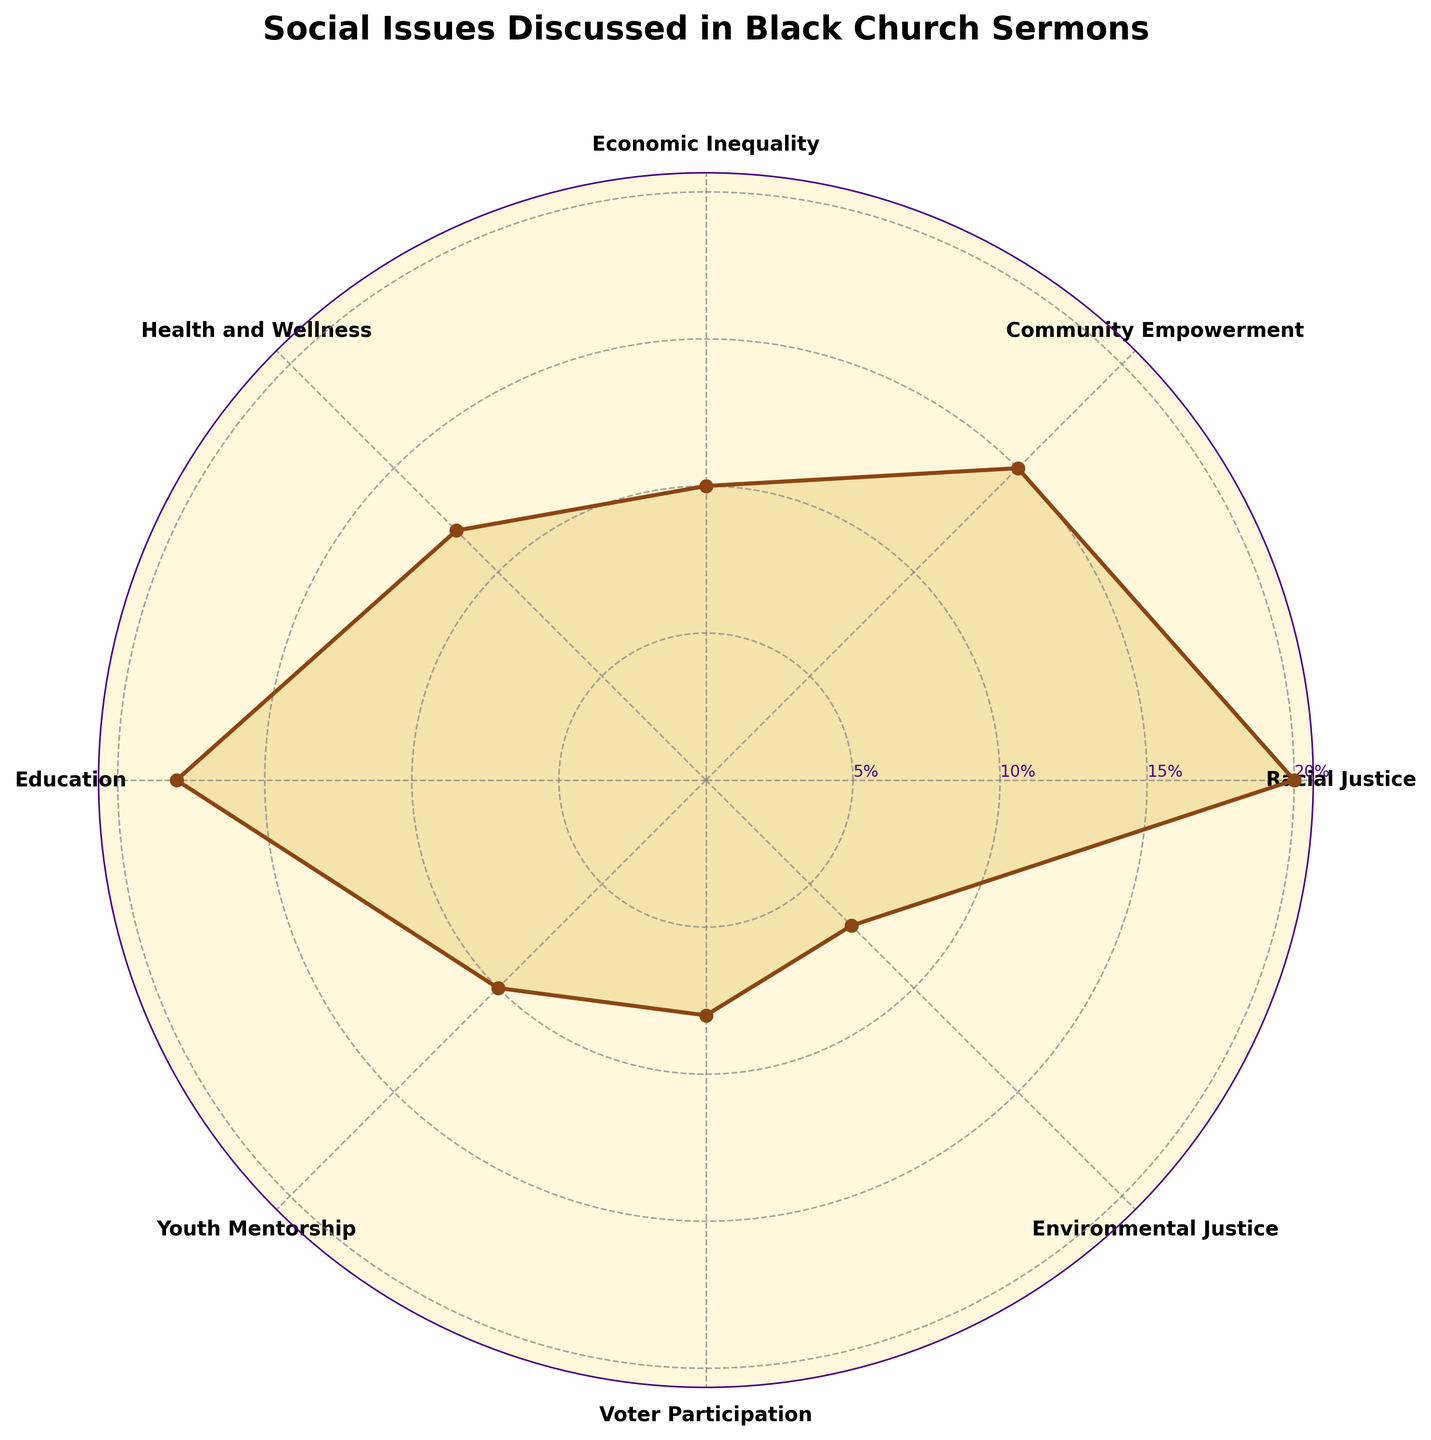What is the title of the plot? The title of the plot is "Social Issues Discussed in Black Church Sermons," which is prominently placed at the top and clearly visible.
Answer: Social Issues Discussed in Black Church Sermons How many social issues are represented in the plot? The plot shows the various categories on the outer radial axis, which totals to eight categories: Racial Justice, Community Empowerment, Economic Inequality, Health and Wellness, Education, Youth Mentorship, Voter Participation, and Environmental Justice.
Answer: Eight Which social issue has the highest percentage discussed in Black church sermons? Look at the radial extent of each category and find which one reaches the furthest point. Racial Justice extends to the 20% mark, making it the highest.
Answer: Racial Justice What is the percentage of sermons discussing Youth Mentorship? Locate Youth Mentorship on the plot and trace the radial lines to the value axis to find the corresponding percentage. Youth Mentorship is marked at the 10% value.
Answer: 10% Combine the percentages of Economic Inequality and Health and Wellness. What’s the total? Find the percentages for both Economic Inequality (10%) and Health and Wellness (12%), and then sum them up: 10% + 12% = 22%.
Answer: 22% Which two social issues have the same percentage? Compare the radial extents of each category and identify if any two lines coincide. Economic Inequality and Youth Mentorship both extend to the 10% mark.
Answer: Economic Inequality and Youth Mentorship What are the categories that have a percentage less than 10%? Look at the radial percentage lines and see which categories fall below the 10% mark. Voter Participation (8%) and Environmental Justice (7%) are both less than 10%.
Answer: Voter Participation and Environmental Justice Which category has a percentage closest to the median percentage value? First, list the percentages: 20, 15, 10, 12, 18, 10, 8, and 7. Sort them in ascending order: 7, 8, 10, 10, 12, 15, 18, 20. The median (middle) value between the 4th and 5th data points is (10+12)/2 = 11. Identify the closest category, which is Health and Wellness (12%).
Answer: Health and Wellness Is Education more frequently discussed than Community Empowerment? Compare the percentages of Education (18%) and Community Empowerment (15%). Since 18% is greater than 15%, Education is indeed more frequently discussed.
Answer: Yes 